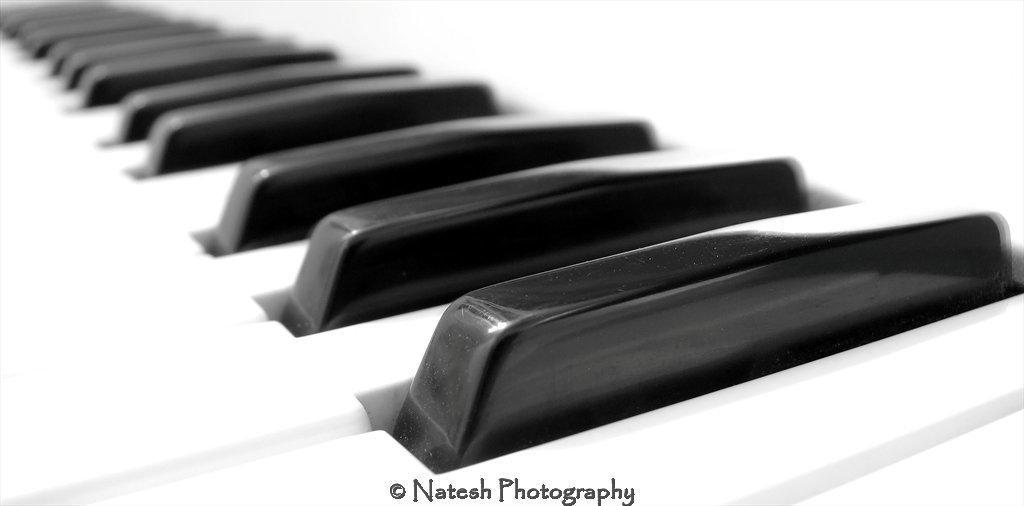In one or two sentences, can you explain what this image depicts? In this picture I can see the keyboard keys in front and they're off white and black in color and I see the watermark on the bottom of the picture and it is blurred in the background. 